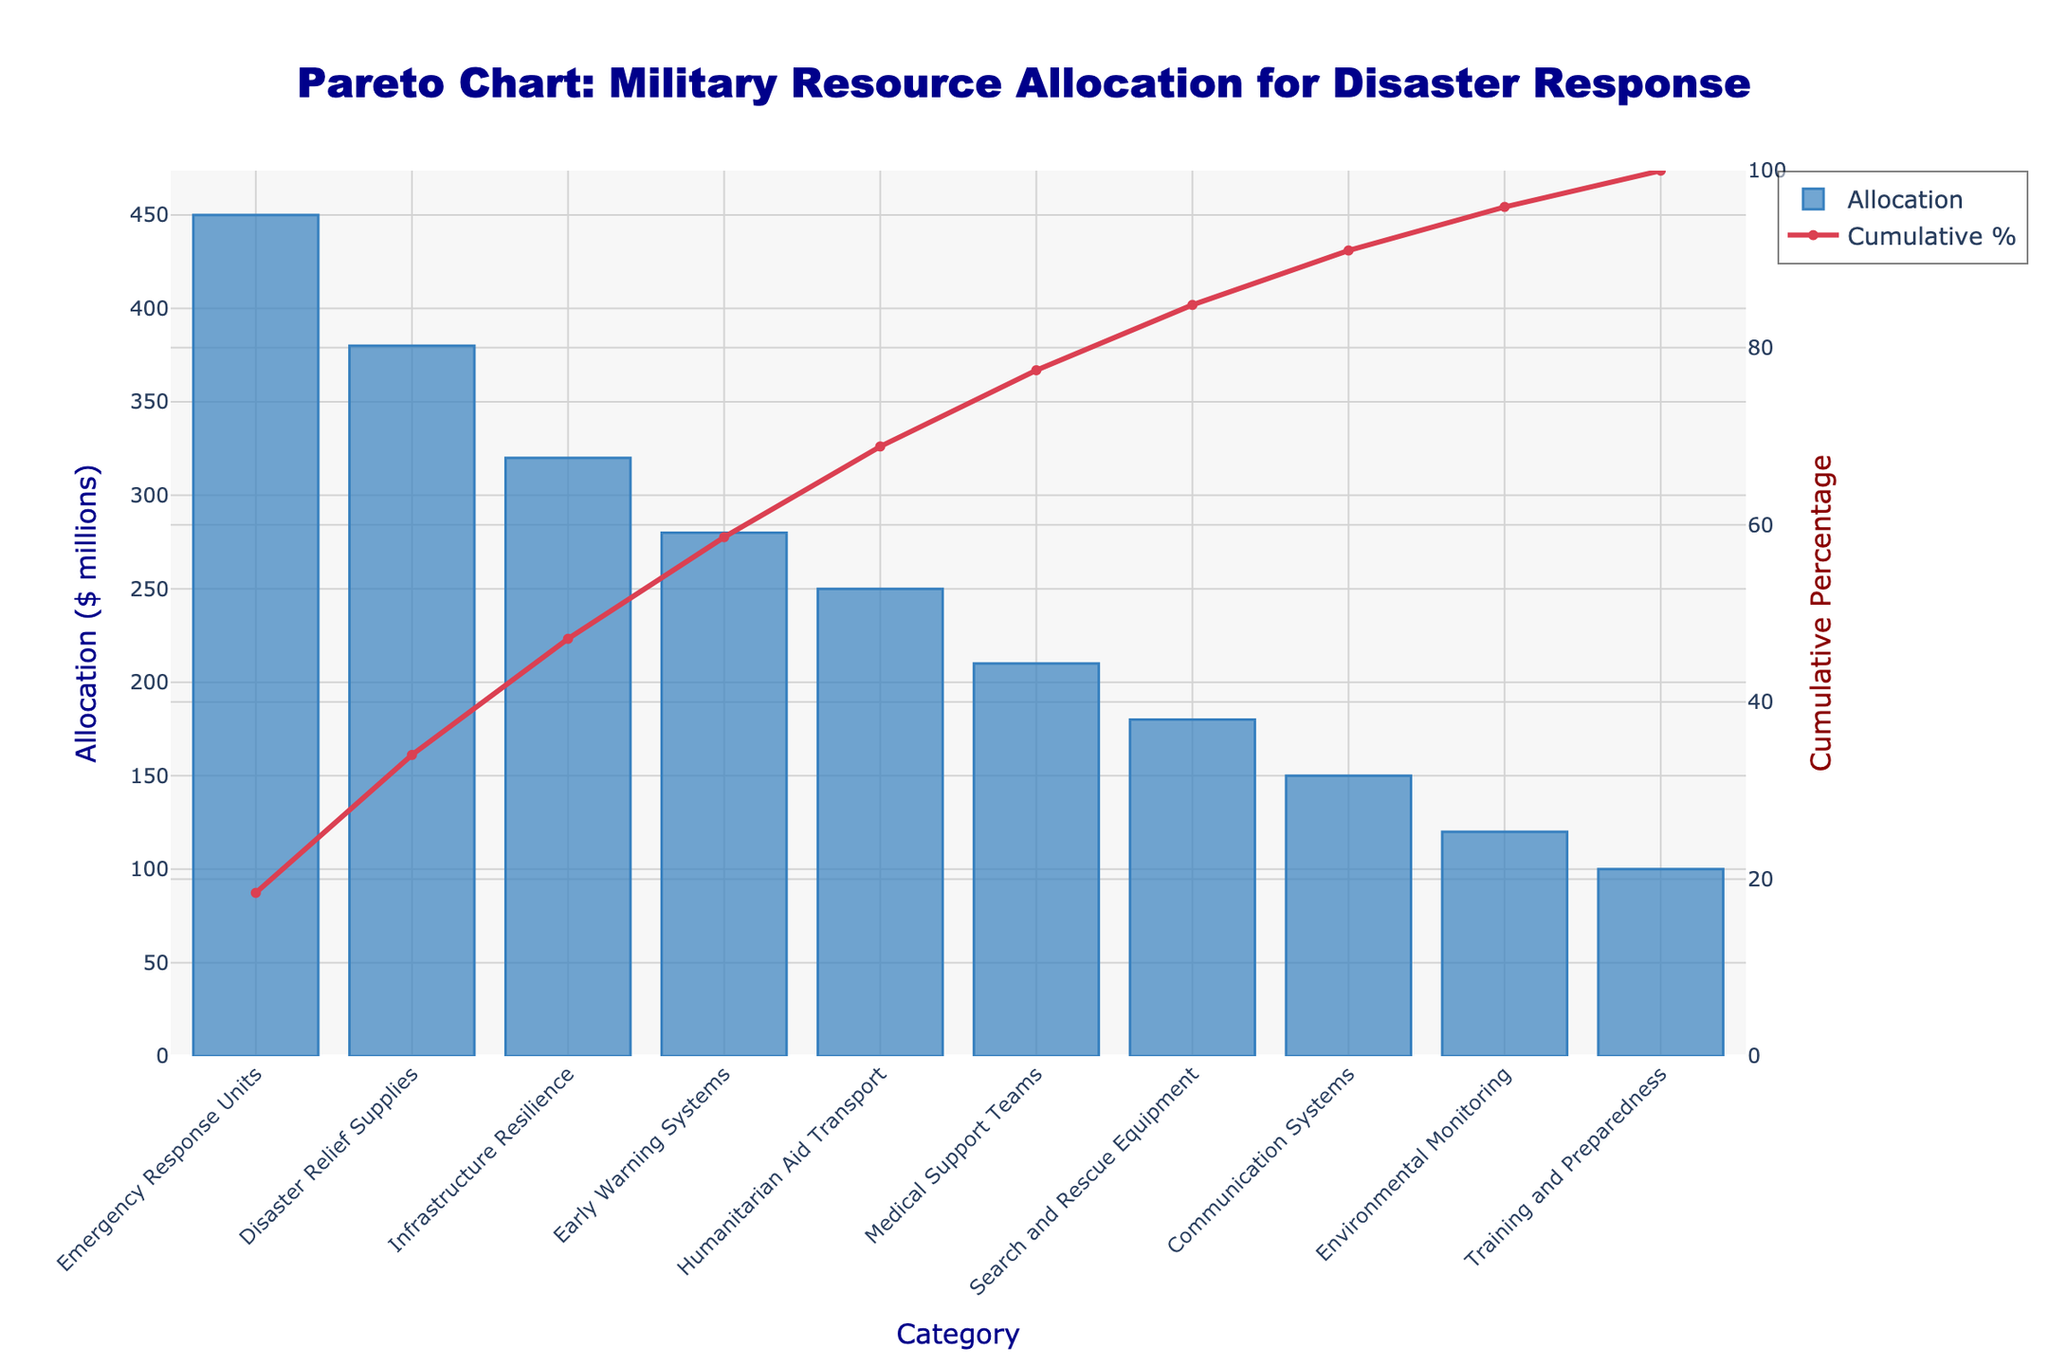What's the title of the Pareto chart? The title is displayed at the top center of the chart in large dark blue font.
Answer: Pareto Chart: Military Resource Allocation for Disaster Response How many categories are shown in the chart? Count the bars on the x-axis, each representing a category.
Answer: 10 Which category has the highest allocation? Identify the tallest bar in the bar chart section.
Answer: Emergency Response Units What is the cumulative percentage for Disaster Relief Supplies? Locate Disaster Relief Supplies on the x-axis, then find the corresponding point on the cumulative percentage line.
Answer: 46.4% How much more is allocated to Emergency Response Units compared to Communication Systems? Subtract the allocation for Communication Systems from the allocation for Emergency Response Units (450 - 150).
Answer: $300 million What's the total allocation for the top three categories? Sum the allocations for Emergency Response Units, Disaster Relief Supplies, and Infrastructure Resilience (450 + 380 + 320).
Answer: $1,150 million Which category corresponds to the first point where the cumulative percentage exceeds 70%? Find the point on the cumulative percentage line just above 70% and note the corresponding category.
Answer: Early Warning Systems What is the cumulative percentage for the top two categories combined? Find the cumulative percentage at the second top category point.
Answer: 46.4% How does the allocation for Medical Support Teams compare with Environmental Monitoring? Find the values for both and compare (210 for Medical Support Teams and 120 for Environmental Monitoring, 210 is greater).
Answer: Medical Support Teams have a higher allocation What's the difference in cumulative percentage between Humanitarian Aid Transport and Medical Support Teams? Subtract the cumulative percentage of Medical Support Teams from that of Humanitarian Aid Transport (84.3% - 65.5%).
Answer: 18.8% 